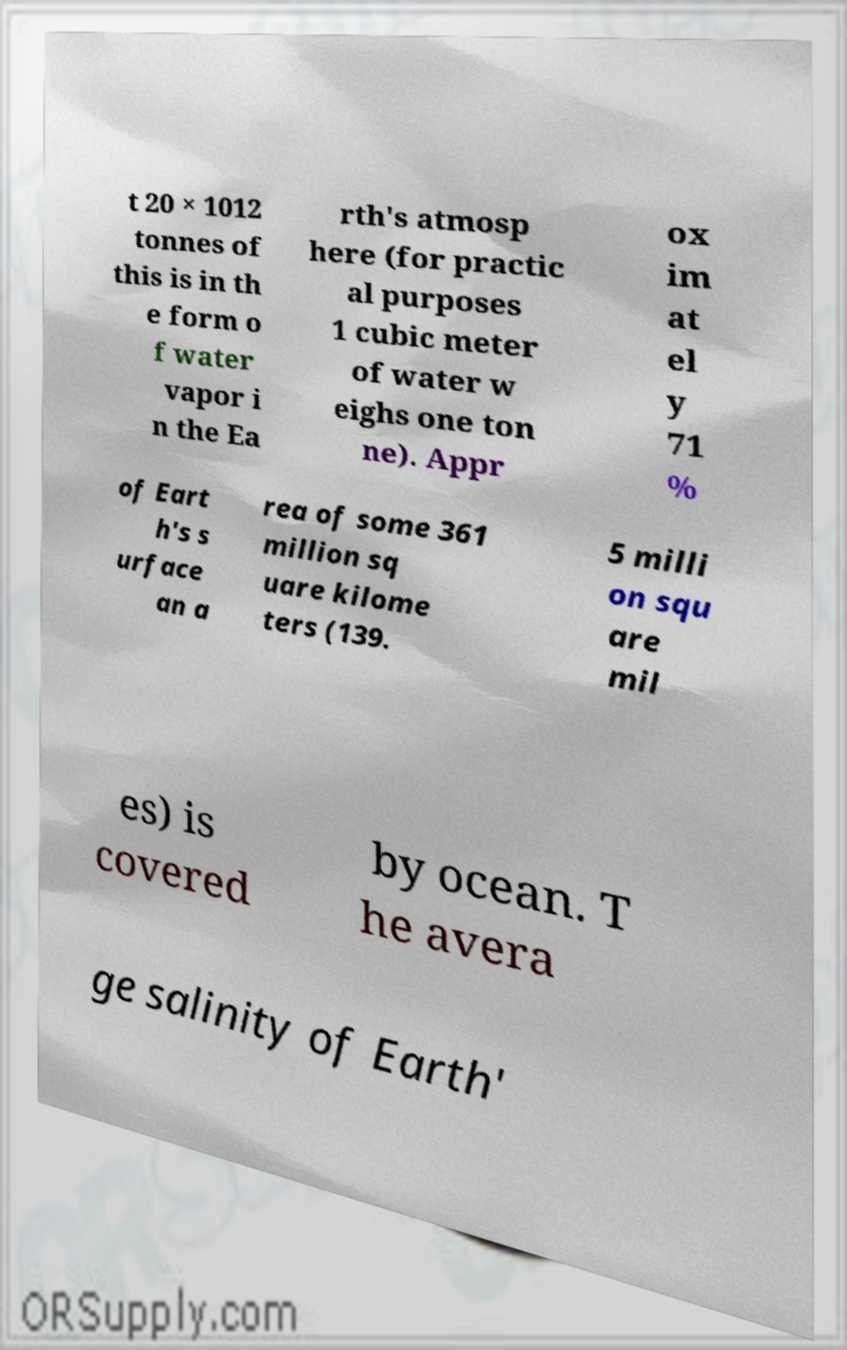What messages or text are displayed in this image? I need them in a readable, typed format. t 20 × 1012 tonnes of this is in th e form o f water vapor i n the Ea rth's atmosp here (for practic al purposes 1 cubic meter of water w eighs one ton ne). Appr ox im at el y 71 % of Eart h's s urface an a rea of some 361 million sq uare kilome ters (139. 5 milli on squ are mil es) is covered by ocean. T he avera ge salinity of Earth' 